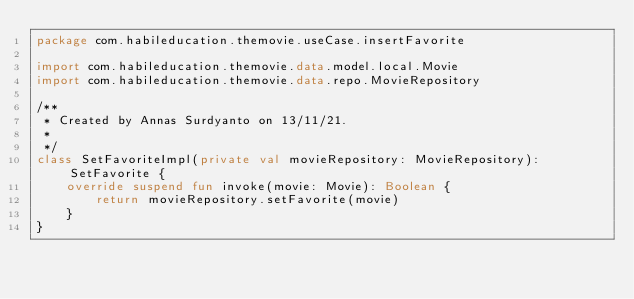Convert code to text. <code><loc_0><loc_0><loc_500><loc_500><_Kotlin_>package com.habileducation.themovie.useCase.insertFavorite

import com.habileducation.themovie.data.model.local.Movie
import com.habileducation.themovie.data.repo.MovieRepository

/**
 * Created by Annas Surdyanto on 13/11/21.
 *
 */
class SetFavoriteImpl(private val movieRepository: MovieRepository): SetFavorite {
    override suspend fun invoke(movie: Movie): Boolean {
        return movieRepository.setFavorite(movie)
    }
}</code> 